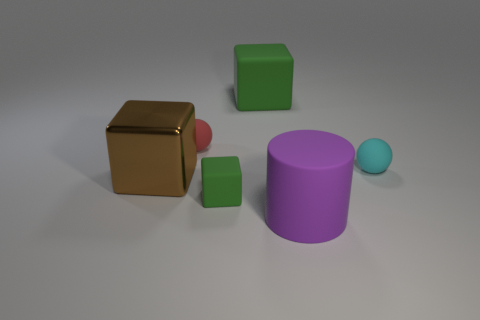What number of big things are both on the right side of the big brown metallic cube and to the left of the large matte block?
Offer a very short reply. 0. There is a tiny green object that is the same material as the red sphere; what shape is it?
Make the answer very short. Cube. There is a green object in front of the tiny cyan matte object; does it have the same size as the object right of the purple matte cylinder?
Make the answer very short. Yes. The rubber block behind the large brown thing is what color?
Provide a succinct answer. Green. What is the material of the big thing that is on the right side of the large cube behind the metal cube?
Offer a very short reply. Rubber. There is a purple matte thing; what shape is it?
Give a very brief answer. Cylinder. There is a small red object that is the same shape as the cyan thing; what material is it?
Your answer should be compact. Rubber. What number of green cubes have the same size as the purple matte object?
Ensure brevity in your answer.  1. There is a green matte cube in front of the big green rubber object; is there a small red object in front of it?
Keep it short and to the point. No. How many brown things are small spheres or small cubes?
Your answer should be very brief. 0. 